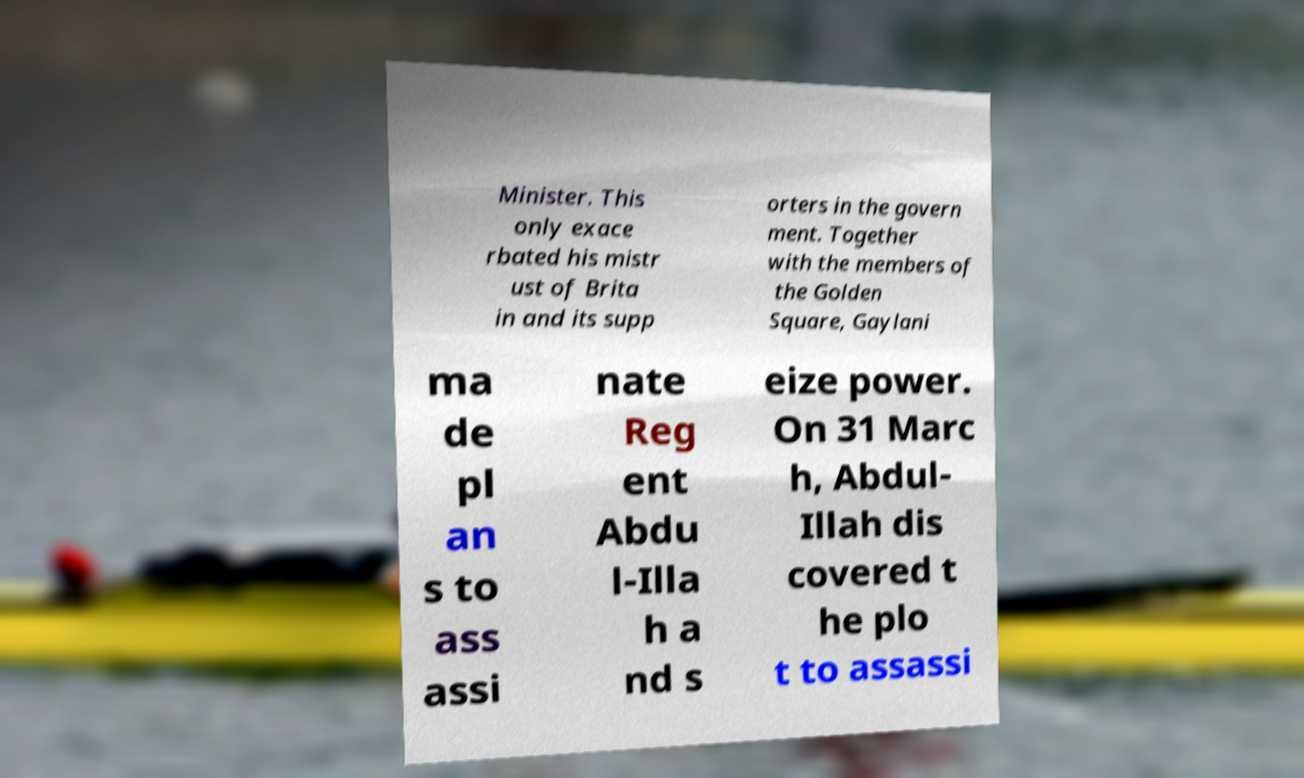I need the written content from this picture converted into text. Can you do that? Minister. This only exace rbated his mistr ust of Brita in and its supp orters in the govern ment. Together with the members of the Golden Square, Gaylani ma de pl an s to ass assi nate Reg ent Abdu l-Illa h a nd s eize power. On 31 Marc h, Abdul- Illah dis covered t he plo t to assassi 